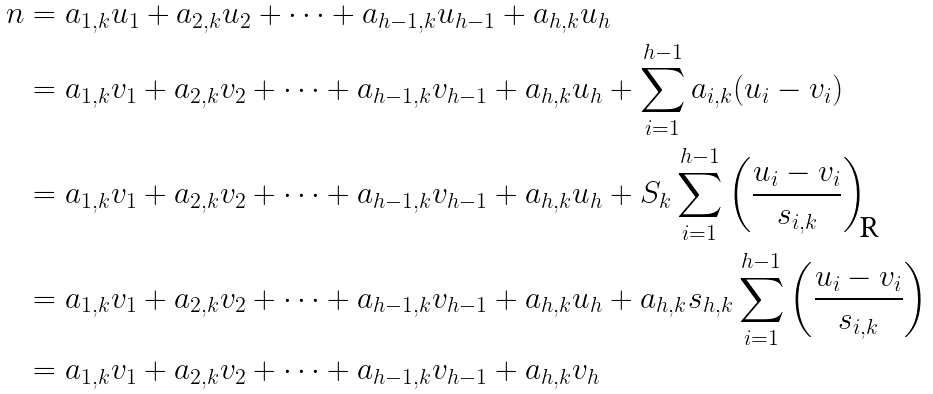Convert formula to latex. <formula><loc_0><loc_0><loc_500><loc_500>n & = a _ { 1 , k } u _ { 1 } + a _ { 2 , k } u _ { 2 } + \cdots + a _ { h - 1 , k } u _ { h - 1 } + a _ { h , k } u _ { h } \\ & = a _ { 1 , k } v _ { 1 } + a _ { 2 , k } v _ { 2 } + \cdots + a _ { h - 1 , k } v _ { h - 1 } + a _ { h , k } u _ { h } + \sum _ { i = 1 } ^ { h - 1 } a _ { i , k } ( u _ { i } - v _ { i } ) \\ & = a _ { 1 , k } v _ { 1 } + a _ { 2 , k } v _ { 2 } + \cdots + a _ { h - 1 , k } v _ { h - 1 } + a _ { h , k } u _ { h } + S _ { k } \sum _ { i = 1 } ^ { h - 1 } \left ( \frac { u _ { i } - v _ { i } } { s _ { i , k } } \right ) \\ & = a _ { 1 , k } v _ { 1 } + a _ { 2 , k } v _ { 2 } + \cdots + a _ { h - 1 , k } v _ { h - 1 } + a _ { h , k } u _ { h } + a _ { h , k } s _ { h , k } \sum _ { i = 1 } ^ { h - 1 } \left ( \frac { u _ { i } - v _ { i } } { s _ { i , k } } \right ) \\ & = a _ { 1 , k } v _ { 1 } + a _ { 2 , k } v _ { 2 } + \cdots + a _ { h - 1 , k } v _ { h - 1 } + a _ { h , k } v _ { h }</formula> 